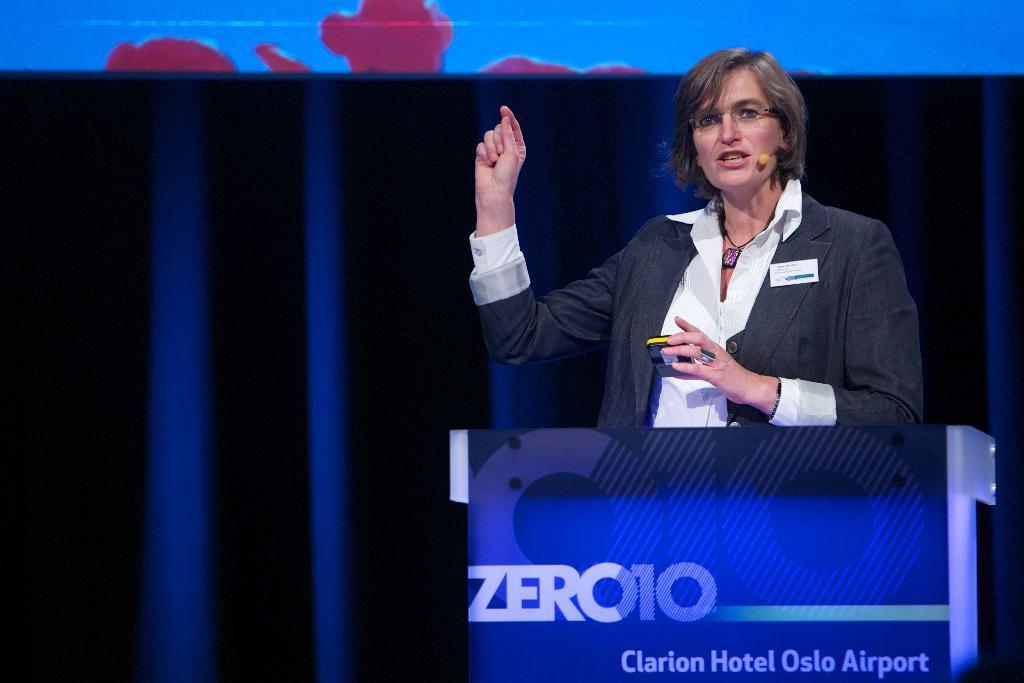Could you give a brief overview of what you see in this image? In this image in center there is one woman who is standing it seems that she is talking and she is holding something, in front of there is one podium and in the background there are some poles and a screen. 